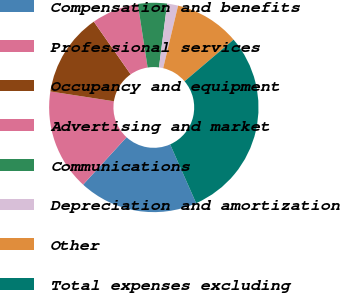Convert chart to OTSL. <chart><loc_0><loc_0><loc_500><loc_500><pie_chart><fcel>Compensation and benefits<fcel>Professional services<fcel>Occupancy and equipment<fcel>Advertising and market<fcel>Communications<fcel>Depreciation and amortization<fcel>Other<fcel>Total expenses excluding<nl><fcel>18.43%<fcel>15.64%<fcel>12.85%<fcel>7.27%<fcel>4.48%<fcel>1.69%<fcel>10.06%<fcel>29.59%<nl></chart> 